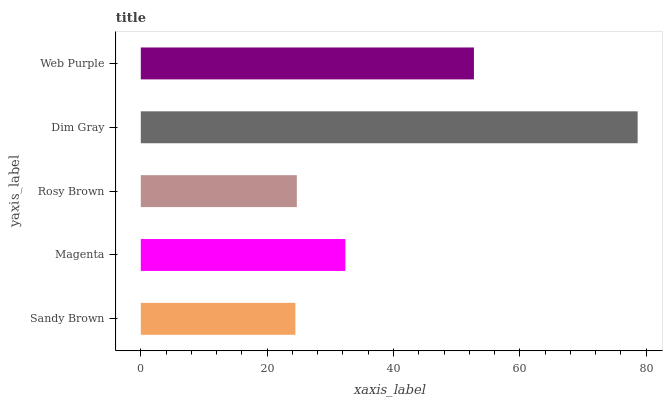Is Sandy Brown the minimum?
Answer yes or no. Yes. Is Dim Gray the maximum?
Answer yes or no. Yes. Is Magenta the minimum?
Answer yes or no. No. Is Magenta the maximum?
Answer yes or no. No. Is Magenta greater than Sandy Brown?
Answer yes or no. Yes. Is Sandy Brown less than Magenta?
Answer yes or no. Yes. Is Sandy Brown greater than Magenta?
Answer yes or no. No. Is Magenta less than Sandy Brown?
Answer yes or no. No. Is Magenta the high median?
Answer yes or no. Yes. Is Magenta the low median?
Answer yes or no. Yes. Is Rosy Brown the high median?
Answer yes or no. No. Is Rosy Brown the low median?
Answer yes or no. No. 